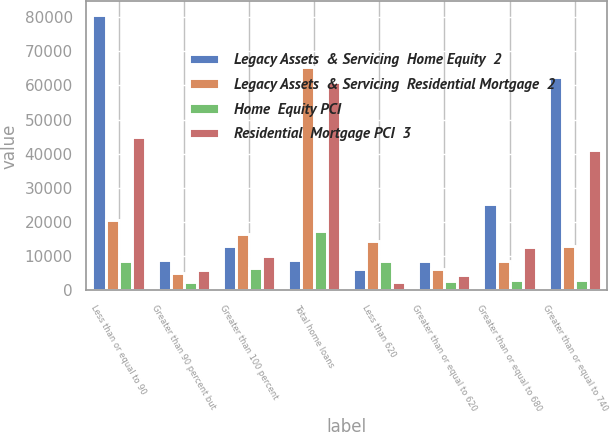Convert chart to OTSL. <chart><loc_0><loc_0><loc_500><loc_500><stacked_bar_chart><ecel><fcel>Less than or equal to 90<fcel>Greater than 90 percent but<fcel>Greater than 100 percent<fcel>Total home loans<fcel>Less than 620<fcel>Greater than or equal to 620<fcel>Greater than or equal to 680<fcel>Greater than or equal to 740<nl><fcel>Legacy Assets  & Servicing  Home Equity  2<fcel>80585<fcel>8891<fcel>12984<fcel>8891<fcel>6366<fcel>8561<fcel>25141<fcel>62392<nl><fcel>Legacy Assets  & Servicing  Residential Mortgage  2<fcel>20613<fcel>5097<fcel>16454<fcel>65362<fcel>14320<fcel>6157<fcel>8611<fcel>13076<nl><fcel>Home  Equity PCI<fcel>8581<fcel>2368<fcel>6502<fcel>17451<fcel>8647<fcel>2712<fcel>2976<fcel>3116<nl><fcel>Residential  Mortgage PCI  3<fcel>44971<fcel>5825<fcel>10055<fcel>60851<fcel>2586<fcel>4500<fcel>12625<fcel>41140<nl></chart> 